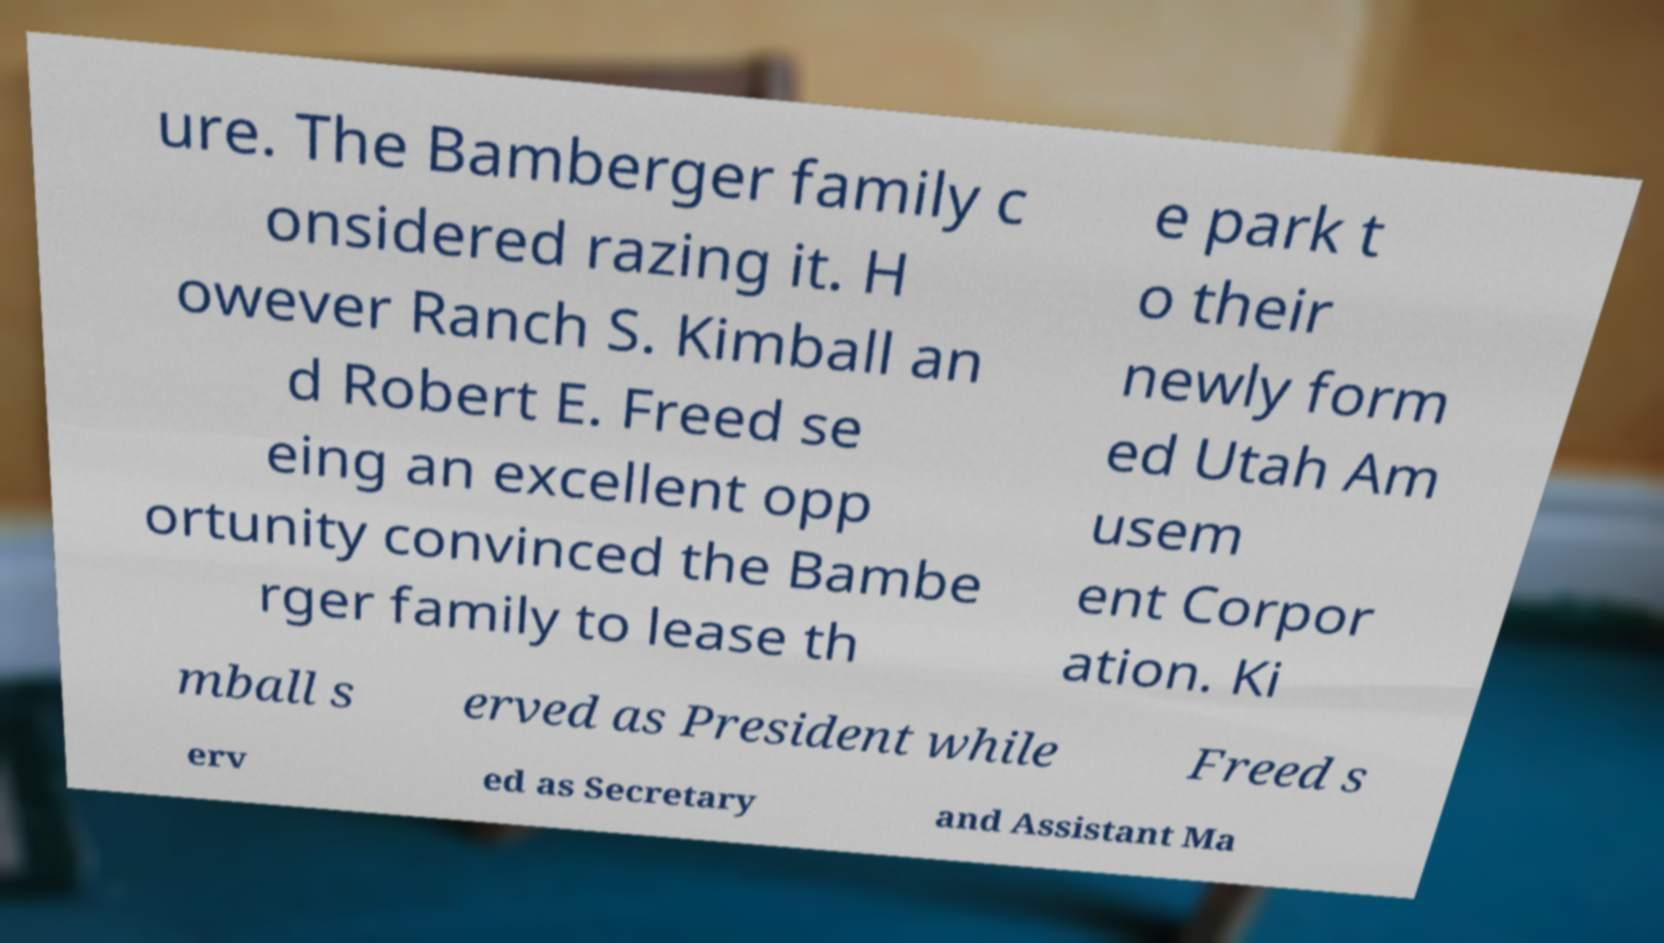Can you read and provide the text displayed in the image?This photo seems to have some interesting text. Can you extract and type it out for me? ure. The Bamberger family c onsidered razing it. H owever Ranch S. Kimball an d Robert E. Freed se eing an excellent opp ortunity convinced the Bambe rger family to lease th e park t o their newly form ed Utah Am usem ent Corpor ation. Ki mball s erved as President while Freed s erv ed as Secretary and Assistant Ma 